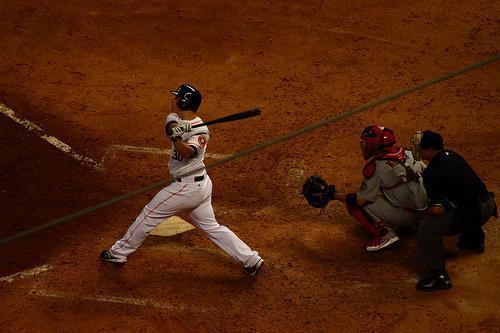How many people are there?
Give a very brief answer. 3. 